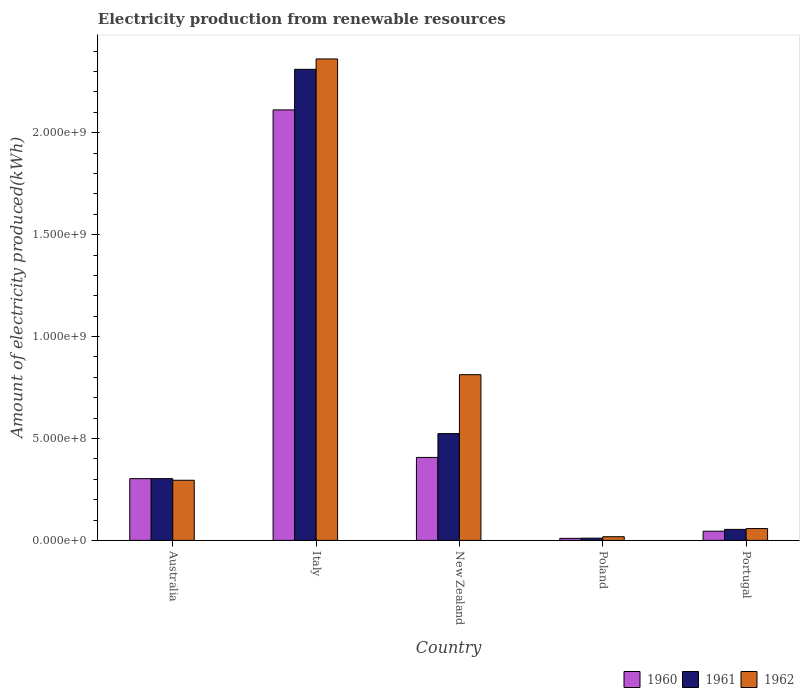How many different coloured bars are there?
Ensure brevity in your answer.  3. How many groups of bars are there?
Your answer should be compact. 5. Are the number of bars on each tick of the X-axis equal?
Keep it short and to the point. Yes. How many bars are there on the 3rd tick from the right?
Your response must be concise. 3. In how many cases, is the number of bars for a given country not equal to the number of legend labels?
Your response must be concise. 0. What is the amount of electricity produced in 1962 in Poland?
Your answer should be very brief. 1.80e+07. Across all countries, what is the maximum amount of electricity produced in 1960?
Your answer should be compact. 2.11e+09. Across all countries, what is the minimum amount of electricity produced in 1960?
Provide a succinct answer. 1.00e+07. In which country was the amount of electricity produced in 1962 minimum?
Ensure brevity in your answer.  Poland. What is the total amount of electricity produced in 1960 in the graph?
Make the answer very short. 2.88e+09. What is the difference between the amount of electricity produced in 1960 in Italy and that in Poland?
Keep it short and to the point. 2.10e+09. What is the difference between the amount of electricity produced in 1962 in Australia and the amount of electricity produced in 1960 in Italy?
Provide a short and direct response. -1.82e+09. What is the average amount of electricity produced in 1960 per country?
Your response must be concise. 5.75e+08. What is the difference between the amount of electricity produced of/in 1962 and amount of electricity produced of/in 1961 in Italy?
Your response must be concise. 5.10e+07. What is the ratio of the amount of electricity produced in 1962 in Australia to that in Poland?
Your response must be concise. 16.39. Is the difference between the amount of electricity produced in 1962 in Italy and New Zealand greater than the difference between the amount of electricity produced in 1961 in Italy and New Zealand?
Keep it short and to the point. No. What is the difference between the highest and the second highest amount of electricity produced in 1961?
Give a very brief answer. 1.79e+09. What is the difference between the highest and the lowest amount of electricity produced in 1962?
Offer a very short reply. 2.34e+09. Is the sum of the amount of electricity produced in 1960 in Australia and New Zealand greater than the maximum amount of electricity produced in 1962 across all countries?
Keep it short and to the point. No. What does the 3rd bar from the left in New Zealand represents?
Your answer should be compact. 1962. What does the 1st bar from the right in Poland represents?
Offer a very short reply. 1962. Are all the bars in the graph horizontal?
Provide a succinct answer. No. How many countries are there in the graph?
Ensure brevity in your answer.  5. Are the values on the major ticks of Y-axis written in scientific E-notation?
Provide a short and direct response. Yes. Does the graph contain any zero values?
Keep it short and to the point. No. How many legend labels are there?
Offer a terse response. 3. How are the legend labels stacked?
Provide a short and direct response. Horizontal. What is the title of the graph?
Your answer should be very brief. Electricity production from renewable resources. What is the label or title of the Y-axis?
Your response must be concise. Amount of electricity produced(kWh). What is the Amount of electricity produced(kWh) of 1960 in Australia?
Offer a terse response. 3.03e+08. What is the Amount of electricity produced(kWh) in 1961 in Australia?
Ensure brevity in your answer.  3.03e+08. What is the Amount of electricity produced(kWh) in 1962 in Australia?
Provide a succinct answer. 2.95e+08. What is the Amount of electricity produced(kWh) of 1960 in Italy?
Offer a very short reply. 2.11e+09. What is the Amount of electricity produced(kWh) in 1961 in Italy?
Your response must be concise. 2.31e+09. What is the Amount of electricity produced(kWh) of 1962 in Italy?
Your answer should be compact. 2.36e+09. What is the Amount of electricity produced(kWh) in 1960 in New Zealand?
Give a very brief answer. 4.07e+08. What is the Amount of electricity produced(kWh) in 1961 in New Zealand?
Your response must be concise. 5.24e+08. What is the Amount of electricity produced(kWh) in 1962 in New Zealand?
Ensure brevity in your answer.  8.13e+08. What is the Amount of electricity produced(kWh) of 1960 in Poland?
Ensure brevity in your answer.  1.00e+07. What is the Amount of electricity produced(kWh) in 1961 in Poland?
Offer a terse response. 1.10e+07. What is the Amount of electricity produced(kWh) of 1962 in Poland?
Provide a succinct answer. 1.80e+07. What is the Amount of electricity produced(kWh) in 1960 in Portugal?
Offer a very short reply. 4.50e+07. What is the Amount of electricity produced(kWh) in 1961 in Portugal?
Offer a very short reply. 5.40e+07. What is the Amount of electricity produced(kWh) of 1962 in Portugal?
Keep it short and to the point. 5.80e+07. Across all countries, what is the maximum Amount of electricity produced(kWh) of 1960?
Give a very brief answer. 2.11e+09. Across all countries, what is the maximum Amount of electricity produced(kWh) of 1961?
Your answer should be compact. 2.31e+09. Across all countries, what is the maximum Amount of electricity produced(kWh) in 1962?
Give a very brief answer. 2.36e+09. Across all countries, what is the minimum Amount of electricity produced(kWh) in 1961?
Offer a very short reply. 1.10e+07. Across all countries, what is the minimum Amount of electricity produced(kWh) in 1962?
Your answer should be very brief. 1.80e+07. What is the total Amount of electricity produced(kWh) of 1960 in the graph?
Provide a short and direct response. 2.88e+09. What is the total Amount of electricity produced(kWh) of 1961 in the graph?
Keep it short and to the point. 3.20e+09. What is the total Amount of electricity produced(kWh) in 1962 in the graph?
Offer a very short reply. 3.55e+09. What is the difference between the Amount of electricity produced(kWh) in 1960 in Australia and that in Italy?
Your response must be concise. -1.81e+09. What is the difference between the Amount of electricity produced(kWh) of 1961 in Australia and that in Italy?
Offer a very short reply. -2.01e+09. What is the difference between the Amount of electricity produced(kWh) of 1962 in Australia and that in Italy?
Provide a short and direct response. -2.07e+09. What is the difference between the Amount of electricity produced(kWh) of 1960 in Australia and that in New Zealand?
Your response must be concise. -1.04e+08. What is the difference between the Amount of electricity produced(kWh) of 1961 in Australia and that in New Zealand?
Keep it short and to the point. -2.21e+08. What is the difference between the Amount of electricity produced(kWh) in 1962 in Australia and that in New Zealand?
Your response must be concise. -5.18e+08. What is the difference between the Amount of electricity produced(kWh) of 1960 in Australia and that in Poland?
Your response must be concise. 2.93e+08. What is the difference between the Amount of electricity produced(kWh) of 1961 in Australia and that in Poland?
Offer a terse response. 2.92e+08. What is the difference between the Amount of electricity produced(kWh) of 1962 in Australia and that in Poland?
Offer a terse response. 2.77e+08. What is the difference between the Amount of electricity produced(kWh) of 1960 in Australia and that in Portugal?
Provide a succinct answer. 2.58e+08. What is the difference between the Amount of electricity produced(kWh) of 1961 in Australia and that in Portugal?
Offer a terse response. 2.49e+08. What is the difference between the Amount of electricity produced(kWh) in 1962 in Australia and that in Portugal?
Your answer should be compact. 2.37e+08. What is the difference between the Amount of electricity produced(kWh) of 1960 in Italy and that in New Zealand?
Ensure brevity in your answer.  1.70e+09. What is the difference between the Amount of electricity produced(kWh) in 1961 in Italy and that in New Zealand?
Offer a very short reply. 1.79e+09. What is the difference between the Amount of electricity produced(kWh) of 1962 in Italy and that in New Zealand?
Make the answer very short. 1.55e+09. What is the difference between the Amount of electricity produced(kWh) in 1960 in Italy and that in Poland?
Offer a very short reply. 2.10e+09. What is the difference between the Amount of electricity produced(kWh) in 1961 in Italy and that in Poland?
Provide a short and direct response. 2.30e+09. What is the difference between the Amount of electricity produced(kWh) in 1962 in Italy and that in Poland?
Your answer should be very brief. 2.34e+09. What is the difference between the Amount of electricity produced(kWh) of 1960 in Italy and that in Portugal?
Provide a succinct answer. 2.07e+09. What is the difference between the Amount of electricity produced(kWh) in 1961 in Italy and that in Portugal?
Provide a short and direct response. 2.26e+09. What is the difference between the Amount of electricity produced(kWh) of 1962 in Italy and that in Portugal?
Your answer should be compact. 2.30e+09. What is the difference between the Amount of electricity produced(kWh) of 1960 in New Zealand and that in Poland?
Offer a very short reply. 3.97e+08. What is the difference between the Amount of electricity produced(kWh) in 1961 in New Zealand and that in Poland?
Provide a succinct answer. 5.13e+08. What is the difference between the Amount of electricity produced(kWh) of 1962 in New Zealand and that in Poland?
Give a very brief answer. 7.95e+08. What is the difference between the Amount of electricity produced(kWh) in 1960 in New Zealand and that in Portugal?
Make the answer very short. 3.62e+08. What is the difference between the Amount of electricity produced(kWh) in 1961 in New Zealand and that in Portugal?
Your answer should be compact. 4.70e+08. What is the difference between the Amount of electricity produced(kWh) of 1962 in New Zealand and that in Portugal?
Make the answer very short. 7.55e+08. What is the difference between the Amount of electricity produced(kWh) in 1960 in Poland and that in Portugal?
Ensure brevity in your answer.  -3.50e+07. What is the difference between the Amount of electricity produced(kWh) of 1961 in Poland and that in Portugal?
Your answer should be very brief. -4.30e+07. What is the difference between the Amount of electricity produced(kWh) of 1962 in Poland and that in Portugal?
Give a very brief answer. -4.00e+07. What is the difference between the Amount of electricity produced(kWh) of 1960 in Australia and the Amount of electricity produced(kWh) of 1961 in Italy?
Your answer should be very brief. -2.01e+09. What is the difference between the Amount of electricity produced(kWh) of 1960 in Australia and the Amount of electricity produced(kWh) of 1962 in Italy?
Your answer should be compact. -2.06e+09. What is the difference between the Amount of electricity produced(kWh) of 1961 in Australia and the Amount of electricity produced(kWh) of 1962 in Italy?
Ensure brevity in your answer.  -2.06e+09. What is the difference between the Amount of electricity produced(kWh) of 1960 in Australia and the Amount of electricity produced(kWh) of 1961 in New Zealand?
Provide a short and direct response. -2.21e+08. What is the difference between the Amount of electricity produced(kWh) in 1960 in Australia and the Amount of electricity produced(kWh) in 1962 in New Zealand?
Make the answer very short. -5.10e+08. What is the difference between the Amount of electricity produced(kWh) of 1961 in Australia and the Amount of electricity produced(kWh) of 1962 in New Zealand?
Offer a terse response. -5.10e+08. What is the difference between the Amount of electricity produced(kWh) in 1960 in Australia and the Amount of electricity produced(kWh) in 1961 in Poland?
Your answer should be very brief. 2.92e+08. What is the difference between the Amount of electricity produced(kWh) of 1960 in Australia and the Amount of electricity produced(kWh) of 1962 in Poland?
Give a very brief answer. 2.85e+08. What is the difference between the Amount of electricity produced(kWh) in 1961 in Australia and the Amount of electricity produced(kWh) in 1962 in Poland?
Your answer should be compact. 2.85e+08. What is the difference between the Amount of electricity produced(kWh) in 1960 in Australia and the Amount of electricity produced(kWh) in 1961 in Portugal?
Give a very brief answer. 2.49e+08. What is the difference between the Amount of electricity produced(kWh) of 1960 in Australia and the Amount of electricity produced(kWh) of 1962 in Portugal?
Make the answer very short. 2.45e+08. What is the difference between the Amount of electricity produced(kWh) of 1961 in Australia and the Amount of electricity produced(kWh) of 1962 in Portugal?
Provide a short and direct response. 2.45e+08. What is the difference between the Amount of electricity produced(kWh) of 1960 in Italy and the Amount of electricity produced(kWh) of 1961 in New Zealand?
Your response must be concise. 1.59e+09. What is the difference between the Amount of electricity produced(kWh) in 1960 in Italy and the Amount of electricity produced(kWh) in 1962 in New Zealand?
Offer a very short reply. 1.30e+09. What is the difference between the Amount of electricity produced(kWh) in 1961 in Italy and the Amount of electricity produced(kWh) in 1962 in New Zealand?
Your answer should be compact. 1.50e+09. What is the difference between the Amount of electricity produced(kWh) of 1960 in Italy and the Amount of electricity produced(kWh) of 1961 in Poland?
Your answer should be compact. 2.10e+09. What is the difference between the Amount of electricity produced(kWh) of 1960 in Italy and the Amount of electricity produced(kWh) of 1962 in Poland?
Give a very brief answer. 2.09e+09. What is the difference between the Amount of electricity produced(kWh) in 1961 in Italy and the Amount of electricity produced(kWh) in 1962 in Poland?
Your response must be concise. 2.29e+09. What is the difference between the Amount of electricity produced(kWh) in 1960 in Italy and the Amount of electricity produced(kWh) in 1961 in Portugal?
Offer a terse response. 2.06e+09. What is the difference between the Amount of electricity produced(kWh) of 1960 in Italy and the Amount of electricity produced(kWh) of 1962 in Portugal?
Your answer should be very brief. 2.05e+09. What is the difference between the Amount of electricity produced(kWh) of 1961 in Italy and the Amount of electricity produced(kWh) of 1962 in Portugal?
Offer a very short reply. 2.25e+09. What is the difference between the Amount of electricity produced(kWh) of 1960 in New Zealand and the Amount of electricity produced(kWh) of 1961 in Poland?
Make the answer very short. 3.96e+08. What is the difference between the Amount of electricity produced(kWh) of 1960 in New Zealand and the Amount of electricity produced(kWh) of 1962 in Poland?
Your answer should be compact. 3.89e+08. What is the difference between the Amount of electricity produced(kWh) of 1961 in New Zealand and the Amount of electricity produced(kWh) of 1962 in Poland?
Give a very brief answer. 5.06e+08. What is the difference between the Amount of electricity produced(kWh) of 1960 in New Zealand and the Amount of electricity produced(kWh) of 1961 in Portugal?
Provide a short and direct response. 3.53e+08. What is the difference between the Amount of electricity produced(kWh) of 1960 in New Zealand and the Amount of electricity produced(kWh) of 1962 in Portugal?
Your response must be concise. 3.49e+08. What is the difference between the Amount of electricity produced(kWh) in 1961 in New Zealand and the Amount of electricity produced(kWh) in 1962 in Portugal?
Give a very brief answer. 4.66e+08. What is the difference between the Amount of electricity produced(kWh) in 1960 in Poland and the Amount of electricity produced(kWh) in 1961 in Portugal?
Your response must be concise. -4.40e+07. What is the difference between the Amount of electricity produced(kWh) in 1960 in Poland and the Amount of electricity produced(kWh) in 1962 in Portugal?
Keep it short and to the point. -4.80e+07. What is the difference between the Amount of electricity produced(kWh) of 1961 in Poland and the Amount of electricity produced(kWh) of 1962 in Portugal?
Provide a succinct answer. -4.70e+07. What is the average Amount of electricity produced(kWh) in 1960 per country?
Offer a terse response. 5.75e+08. What is the average Amount of electricity produced(kWh) of 1961 per country?
Keep it short and to the point. 6.41e+08. What is the average Amount of electricity produced(kWh) of 1962 per country?
Make the answer very short. 7.09e+08. What is the difference between the Amount of electricity produced(kWh) of 1960 and Amount of electricity produced(kWh) of 1961 in Australia?
Keep it short and to the point. 0. What is the difference between the Amount of electricity produced(kWh) in 1960 and Amount of electricity produced(kWh) in 1961 in Italy?
Your response must be concise. -1.99e+08. What is the difference between the Amount of electricity produced(kWh) of 1960 and Amount of electricity produced(kWh) of 1962 in Italy?
Offer a terse response. -2.50e+08. What is the difference between the Amount of electricity produced(kWh) of 1961 and Amount of electricity produced(kWh) of 1962 in Italy?
Provide a succinct answer. -5.10e+07. What is the difference between the Amount of electricity produced(kWh) of 1960 and Amount of electricity produced(kWh) of 1961 in New Zealand?
Offer a terse response. -1.17e+08. What is the difference between the Amount of electricity produced(kWh) of 1960 and Amount of electricity produced(kWh) of 1962 in New Zealand?
Make the answer very short. -4.06e+08. What is the difference between the Amount of electricity produced(kWh) in 1961 and Amount of electricity produced(kWh) in 1962 in New Zealand?
Ensure brevity in your answer.  -2.89e+08. What is the difference between the Amount of electricity produced(kWh) of 1960 and Amount of electricity produced(kWh) of 1962 in Poland?
Ensure brevity in your answer.  -8.00e+06. What is the difference between the Amount of electricity produced(kWh) of 1961 and Amount of electricity produced(kWh) of 1962 in Poland?
Offer a terse response. -7.00e+06. What is the difference between the Amount of electricity produced(kWh) of 1960 and Amount of electricity produced(kWh) of 1961 in Portugal?
Offer a terse response. -9.00e+06. What is the difference between the Amount of electricity produced(kWh) in 1960 and Amount of electricity produced(kWh) in 1962 in Portugal?
Provide a short and direct response. -1.30e+07. What is the difference between the Amount of electricity produced(kWh) in 1961 and Amount of electricity produced(kWh) in 1962 in Portugal?
Give a very brief answer. -4.00e+06. What is the ratio of the Amount of electricity produced(kWh) of 1960 in Australia to that in Italy?
Your answer should be compact. 0.14. What is the ratio of the Amount of electricity produced(kWh) of 1961 in Australia to that in Italy?
Provide a short and direct response. 0.13. What is the ratio of the Amount of electricity produced(kWh) of 1962 in Australia to that in Italy?
Give a very brief answer. 0.12. What is the ratio of the Amount of electricity produced(kWh) of 1960 in Australia to that in New Zealand?
Offer a very short reply. 0.74. What is the ratio of the Amount of electricity produced(kWh) in 1961 in Australia to that in New Zealand?
Provide a succinct answer. 0.58. What is the ratio of the Amount of electricity produced(kWh) of 1962 in Australia to that in New Zealand?
Offer a terse response. 0.36. What is the ratio of the Amount of electricity produced(kWh) of 1960 in Australia to that in Poland?
Provide a short and direct response. 30.3. What is the ratio of the Amount of electricity produced(kWh) of 1961 in Australia to that in Poland?
Offer a terse response. 27.55. What is the ratio of the Amount of electricity produced(kWh) of 1962 in Australia to that in Poland?
Your answer should be compact. 16.39. What is the ratio of the Amount of electricity produced(kWh) in 1960 in Australia to that in Portugal?
Ensure brevity in your answer.  6.73. What is the ratio of the Amount of electricity produced(kWh) of 1961 in Australia to that in Portugal?
Your answer should be very brief. 5.61. What is the ratio of the Amount of electricity produced(kWh) of 1962 in Australia to that in Portugal?
Keep it short and to the point. 5.09. What is the ratio of the Amount of electricity produced(kWh) in 1960 in Italy to that in New Zealand?
Offer a terse response. 5.19. What is the ratio of the Amount of electricity produced(kWh) of 1961 in Italy to that in New Zealand?
Your answer should be very brief. 4.41. What is the ratio of the Amount of electricity produced(kWh) in 1962 in Italy to that in New Zealand?
Provide a short and direct response. 2.91. What is the ratio of the Amount of electricity produced(kWh) of 1960 in Italy to that in Poland?
Your answer should be very brief. 211.2. What is the ratio of the Amount of electricity produced(kWh) in 1961 in Italy to that in Poland?
Provide a succinct answer. 210.09. What is the ratio of the Amount of electricity produced(kWh) of 1962 in Italy to that in Poland?
Offer a terse response. 131.22. What is the ratio of the Amount of electricity produced(kWh) in 1960 in Italy to that in Portugal?
Ensure brevity in your answer.  46.93. What is the ratio of the Amount of electricity produced(kWh) of 1961 in Italy to that in Portugal?
Your response must be concise. 42.8. What is the ratio of the Amount of electricity produced(kWh) of 1962 in Italy to that in Portugal?
Give a very brief answer. 40.72. What is the ratio of the Amount of electricity produced(kWh) in 1960 in New Zealand to that in Poland?
Your response must be concise. 40.7. What is the ratio of the Amount of electricity produced(kWh) of 1961 in New Zealand to that in Poland?
Your answer should be very brief. 47.64. What is the ratio of the Amount of electricity produced(kWh) of 1962 in New Zealand to that in Poland?
Keep it short and to the point. 45.17. What is the ratio of the Amount of electricity produced(kWh) of 1960 in New Zealand to that in Portugal?
Ensure brevity in your answer.  9.04. What is the ratio of the Amount of electricity produced(kWh) of 1961 in New Zealand to that in Portugal?
Give a very brief answer. 9.7. What is the ratio of the Amount of electricity produced(kWh) in 1962 in New Zealand to that in Portugal?
Provide a succinct answer. 14.02. What is the ratio of the Amount of electricity produced(kWh) of 1960 in Poland to that in Portugal?
Make the answer very short. 0.22. What is the ratio of the Amount of electricity produced(kWh) of 1961 in Poland to that in Portugal?
Keep it short and to the point. 0.2. What is the ratio of the Amount of electricity produced(kWh) of 1962 in Poland to that in Portugal?
Provide a short and direct response. 0.31. What is the difference between the highest and the second highest Amount of electricity produced(kWh) of 1960?
Keep it short and to the point. 1.70e+09. What is the difference between the highest and the second highest Amount of electricity produced(kWh) of 1961?
Your answer should be very brief. 1.79e+09. What is the difference between the highest and the second highest Amount of electricity produced(kWh) of 1962?
Your answer should be very brief. 1.55e+09. What is the difference between the highest and the lowest Amount of electricity produced(kWh) of 1960?
Provide a short and direct response. 2.10e+09. What is the difference between the highest and the lowest Amount of electricity produced(kWh) in 1961?
Ensure brevity in your answer.  2.30e+09. What is the difference between the highest and the lowest Amount of electricity produced(kWh) in 1962?
Provide a short and direct response. 2.34e+09. 